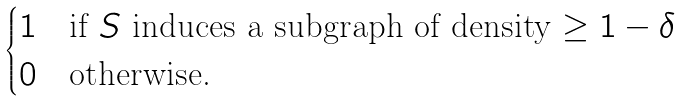<formula> <loc_0><loc_0><loc_500><loc_500>\begin{cases} 1 \quad \text {if $S$ induces a subgraph of density $\geq 1-\delta$} \\ 0 \quad \text {otherwise.} \end{cases}</formula> 